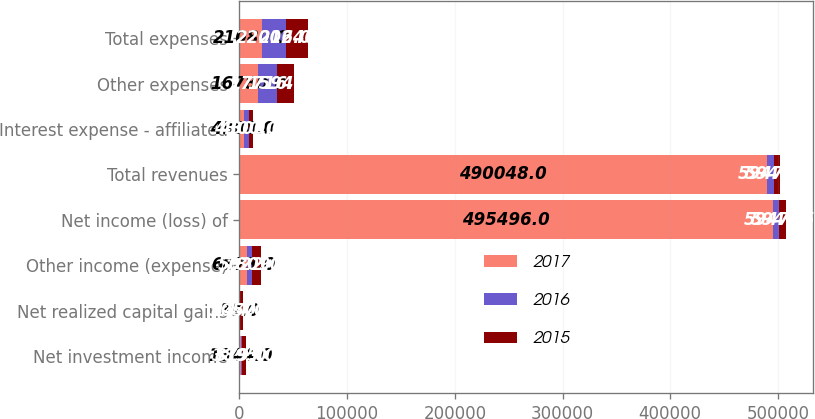Convert chart. <chart><loc_0><loc_0><loc_500><loc_500><stacked_bar_chart><ecel><fcel>Net investment income<fcel>Net realized capital gains<fcel>Other income (expense)<fcel>Net income (loss) of<fcel>Total revenues<fcel>Interest expense - affiliated<fcel>Other expenses<fcel>Total expenses<nl><fcel>2017<fcel>1344<fcel>80<fcel>6873<fcel>495496<fcel>490048<fcel>4300<fcel>16780<fcel>21080<nl><fcel>2016<fcel>879<fcel>144<fcel>5022<fcel>5947.5<fcel>5947.5<fcel>4300<fcel>17716<fcel>22016<nl><fcel>2015<fcel>3895<fcel>3057<fcel>7809<fcel>5947.5<fcel>5947.5<fcel>4300<fcel>15940<fcel>20240<nl></chart> 